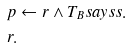<formula> <loc_0><loc_0><loc_500><loc_500>& p \leftarrow r \land T _ { B } s a y s s . \\ & r .</formula> 